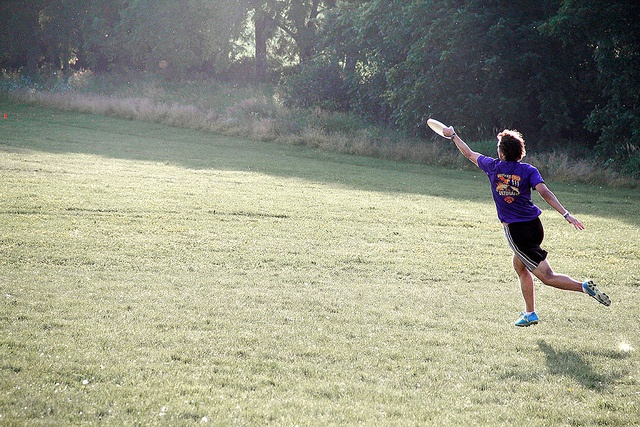Describe the objects in this image and their specific colors. I can see people in black, navy, gray, and brown tones and frisbee in black, white, tan, pink, and darkgray tones in this image. 